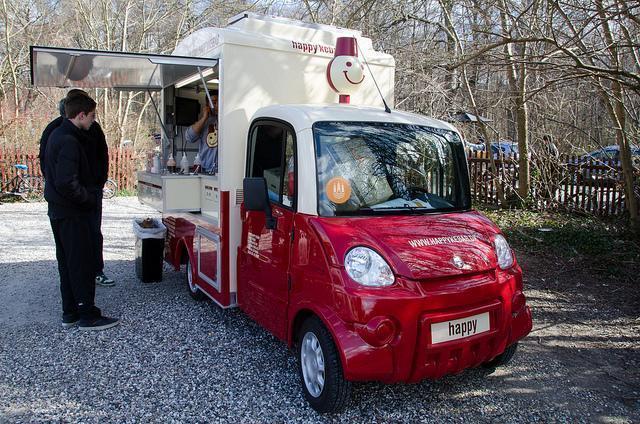Where could someone put their garbage?
Answer the question by selecting the correct answer among the 4 following choices.
Options: Cab, kitchen, rubbish bin, forest ground. Rubbish bin. 